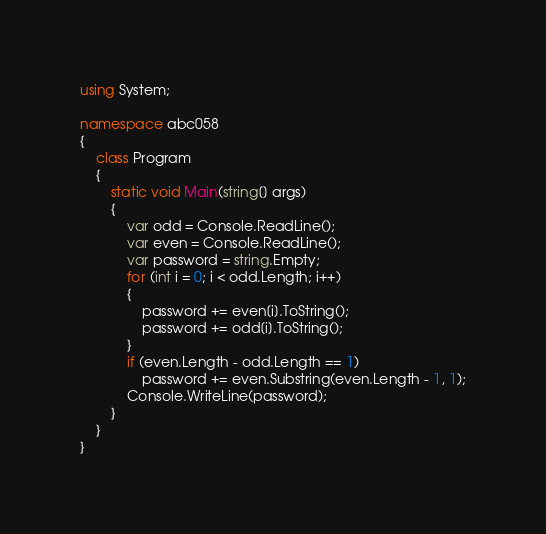Convert code to text. <code><loc_0><loc_0><loc_500><loc_500><_C#_>using System;

namespace abc058
{
    class Program
    {
        static void Main(string[] args)
        {
            var odd = Console.ReadLine();
            var even = Console.ReadLine();
            var password = string.Empty;
            for (int i = 0; i < odd.Length; i++)
            {
                password += even[i].ToString();
                password += odd[i].ToString();
            }
            if (even.Length - odd.Length == 1)
                password += even.Substring(even.Length - 1, 1);
            Console.WriteLine(password);
        }
    }
}
</code> 